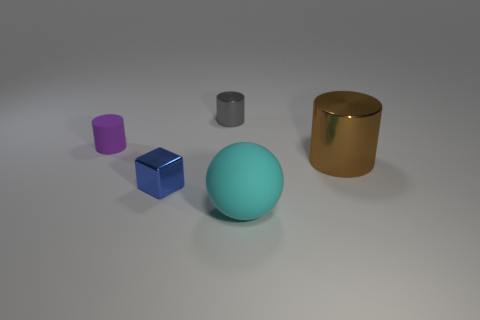Subtract all metal cylinders. How many cylinders are left? 1 Add 3 big brown metallic things. How many objects exist? 8 Subtract all gray cylinders. How many cylinders are left? 2 Subtract all blocks. How many objects are left? 4 Subtract 0 green blocks. How many objects are left? 5 Subtract 1 cylinders. How many cylinders are left? 2 Subtract all purple cubes. Subtract all green cylinders. How many cubes are left? 1 Subtract all small yellow matte balls. Subtract all cyan objects. How many objects are left? 4 Add 3 balls. How many balls are left? 4 Add 5 large cyan objects. How many large cyan objects exist? 6 